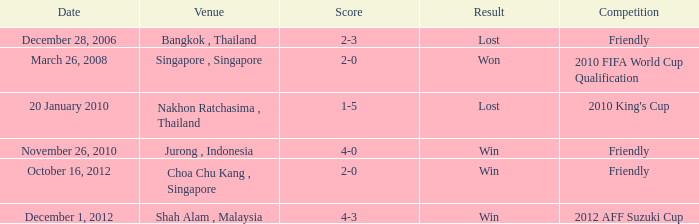Specify the place for cordial rivalry on october 16, 201 Choa Chu Kang , Singapore. Would you mind parsing the complete table? {'header': ['Date', 'Venue', 'Score', 'Result', 'Competition'], 'rows': [['December 28, 2006', 'Bangkok , Thailand', '2-3', 'Lost', 'Friendly'], ['March 26, 2008', 'Singapore , Singapore', '2-0', 'Won', '2010 FIFA World Cup Qualification'], ['20 January 2010', 'Nakhon Ratchasima , Thailand', '1-5', 'Lost', "2010 King's Cup"], ['November 26, 2010', 'Jurong , Indonesia', '4-0', 'Win', 'Friendly'], ['October 16, 2012', 'Choa Chu Kang , Singapore', '2-0', 'Win', 'Friendly'], ['December 1, 2012', 'Shah Alam , Malaysia', '4-3', 'Win', '2012 AFF Suzuki Cup']]} 